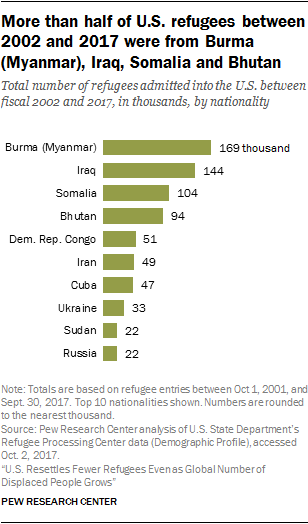Outline some significant characteristics in this image. Eight bars out of the graph have a value that is greater than the smallest bar. The value of the longest bar is 169. 